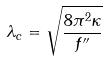<formula> <loc_0><loc_0><loc_500><loc_500>\lambda _ { c } = \sqrt { \frac { 8 \pi ^ { 2 } \kappa } { f ^ { \prime \prime } } }</formula> 